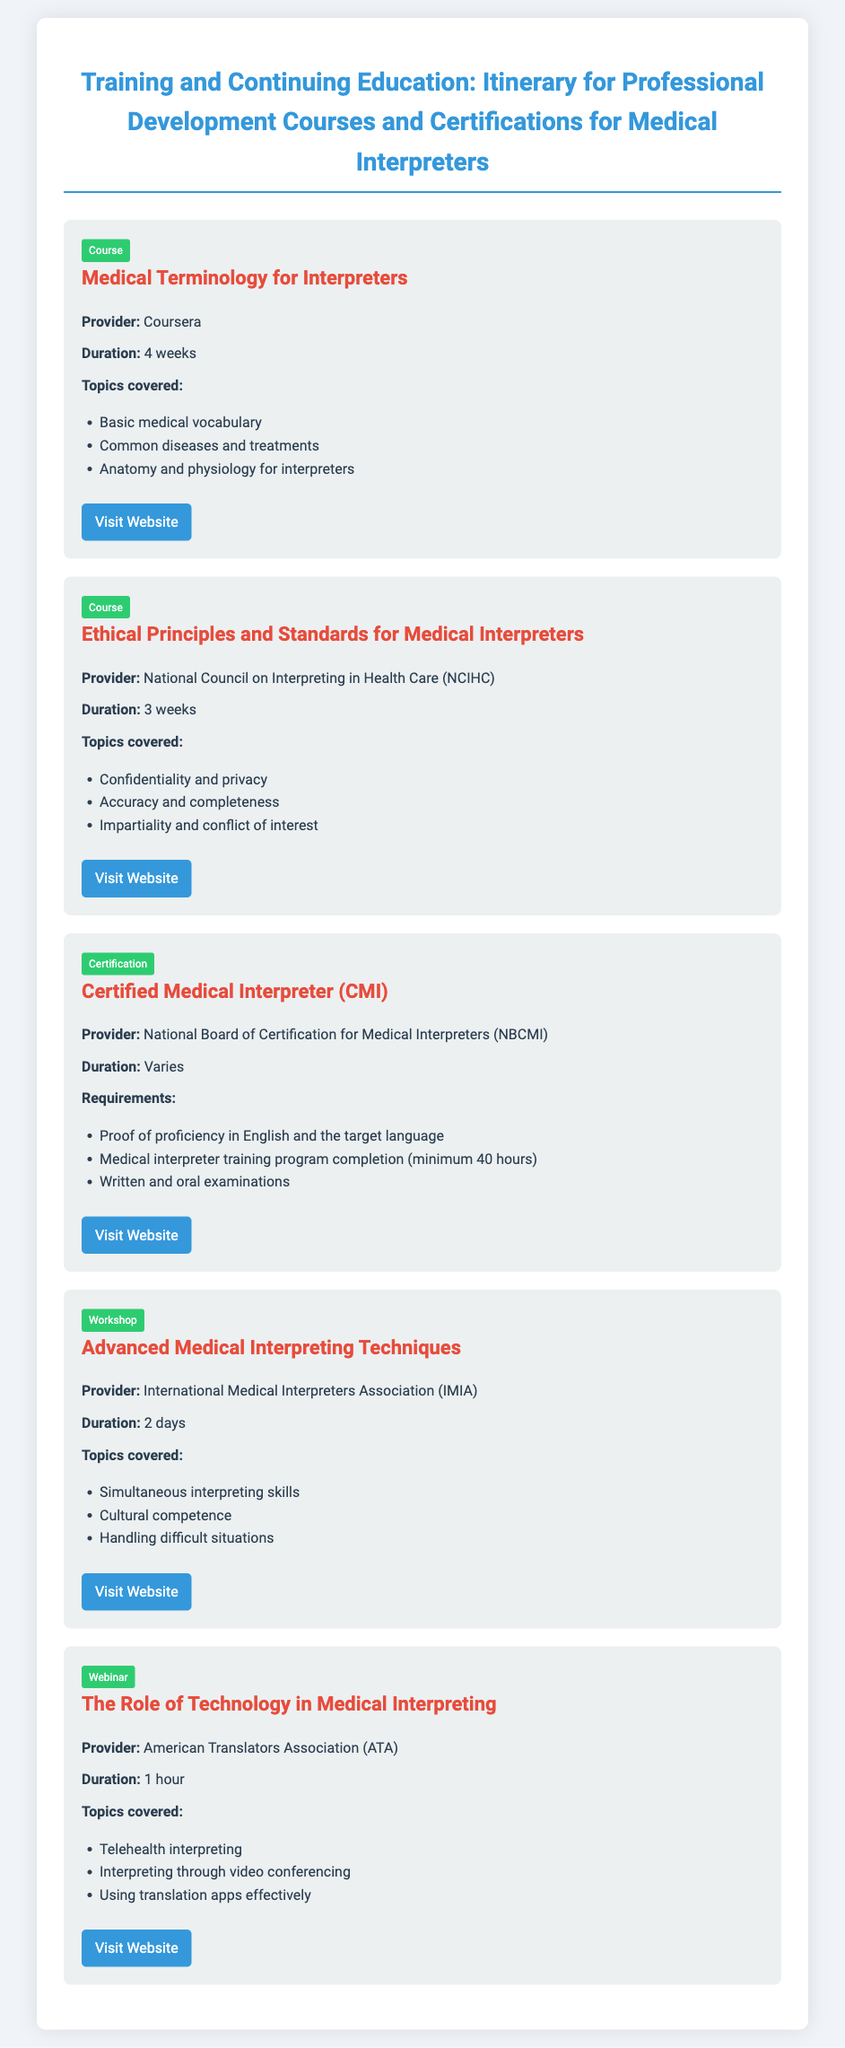What is the duration of the Medical Terminology for Interpreters course? The duration of the course is mentioned as 4 weeks.
Answer: 4 weeks Who is the provider of the Ethical Principles and Standards for Medical Interpreters course? The provider is specifically stated as the National Council on Interpreting in Health Care (NCIHC).
Answer: National Council on Interpreting in Health Care (NCIHC) What are the topics covered in the Advanced Medical Interpreting Techniques workshop? The topics covered include simultaneous interpreting skills, cultural competence, and handling difficult situations.
Answer: Simultaneous interpreting skills, cultural competence, handling difficult situations What is a requirement for the Certified Medical Interpreter (CMI) certification? A requirement is proof of proficiency in English and the target language.
Answer: Proof of proficiency in English and the target language How long is the duration of the webinar on The Role of Technology in Medical Interpreting? The duration of the webinar is specified as 1 hour.
Answer: 1 hour What type of course is the Medical Terminology for Interpreters? The course type is categorized under Course.
Answer: Course Which organization offers the Certified Medical Interpreter (CMI)? The provider of the certification is stated as the National Board of Certification for Medical Interpreters (NBCMI).
Answer: National Board of Certification for Medical Interpreters (NBCMI) How many days does the Advanced Medical Interpreting Techniques workshop last? The document mentions that the workshop lasts for 2 days.
Answer: 2 days 